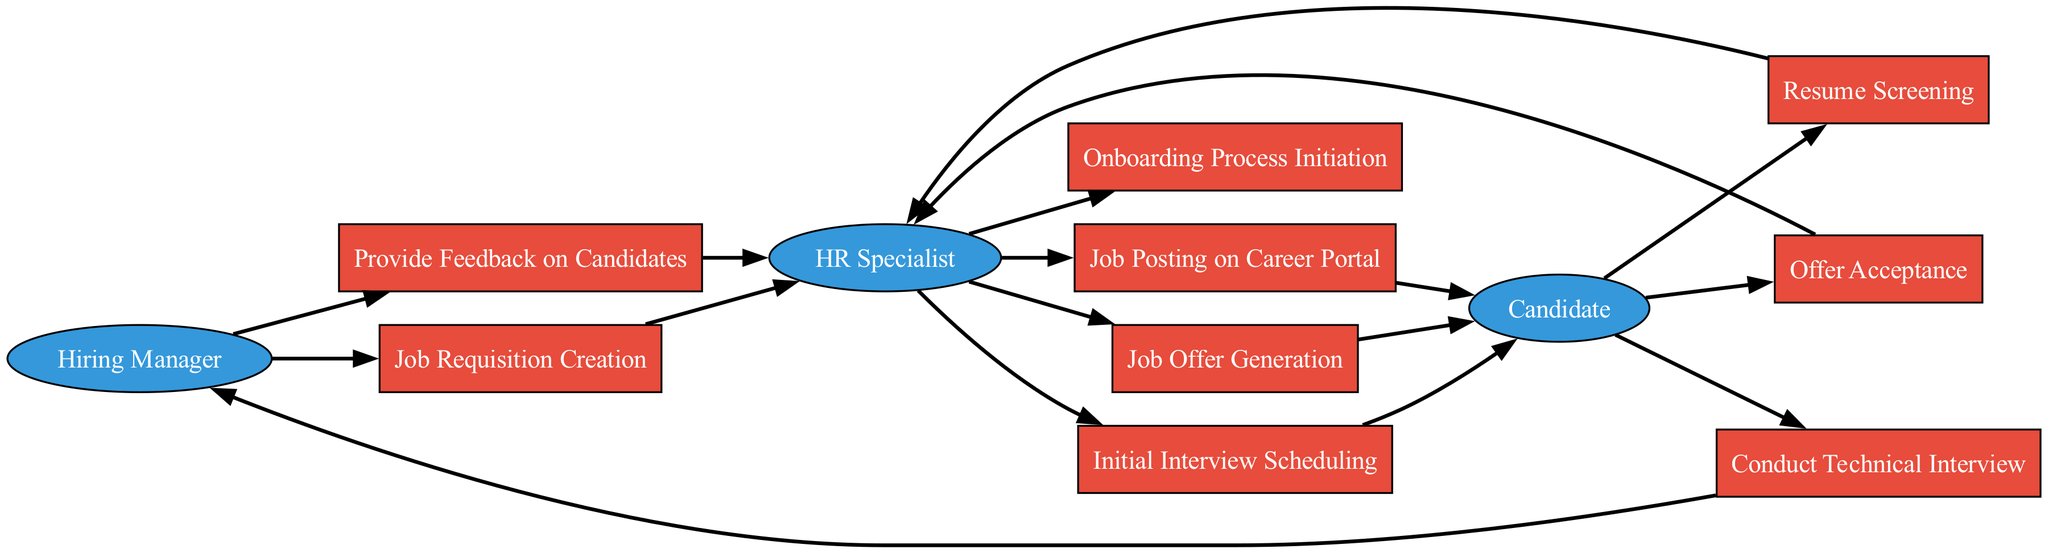What's the first process initiated by the Hiring Manager? The Hiring Manager starts the process by creating a Job Requisition, which is the first process in the sequence.
Answer: Job Requisition Creation How many actors are present in the diagram? There are three actors involved in the talent acquisition process: Hiring Manager, HR Specialist, and Candidate.
Answer: Three Which process comes after the Candidate screens the resumes? After the Candidate submits their resume, the next process is the Resume Screening, performed by the HR Specialist.
Answer: Resume Screening Who generates the Job Offer? The Job Offer is generated by the HR Specialist after evaluating candidate responses and feedback from the Hiring Manager.
Answer: HR Specialist What is the last process in the talent acquisition workflow? The last process initiated in the sequence is the Onboarding Process Initiation, which occurs after the offer acceptance.
Answer: Onboarding Process Initiation What step follows the Conduct Technical Interview? After conducting the Technical Interview, the next step is for the Hiring Manager to Provide Feedback on Candidates.
Answer: Provide Feedback on Candidates How many processes are involved in this talent acquisition process? There are a total of eight processes involved in the talent acquisition process as depicted in the diagram.
Answer: Eight Which actor is involved in the Initial Interview Scheduling? The HR Specialist is responsible for scheduling the Initial Interview after completing the Resume Screening.
Answer: HR Specialist From which process does the Candidate first interact with the system? The Candidate first interacts with the system when they view the Job Posting on the Career Portal.
Answer: Job Posting on Career Portal 